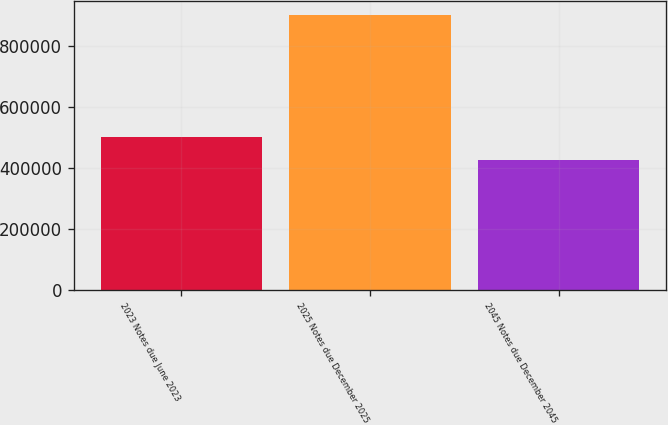Convert chart to OTSL. <chart><loc_0><loc_0><loc_500><loc_500><bar_chart><fcel>2023 Notes due June 2023<fcel>2025 Notes due December 2025<fcel>2045 Notes due December 2045<nl><fcel>501307<fcel>901523<fcel>425109<nl></chart> 